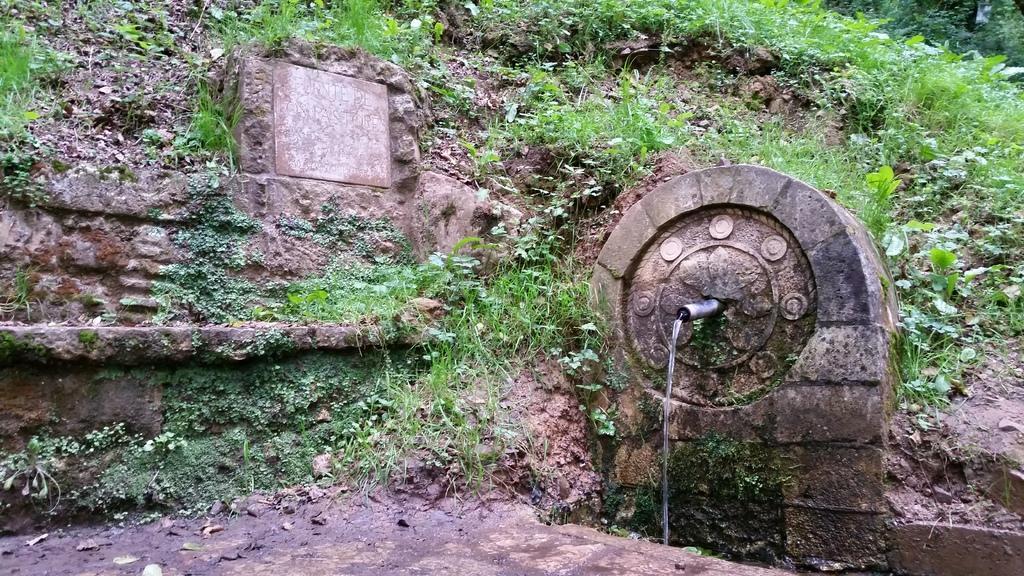Describe this image in one or two sentences. In this image I can see the water coming from an object. In the background I can see the grass and plants. 